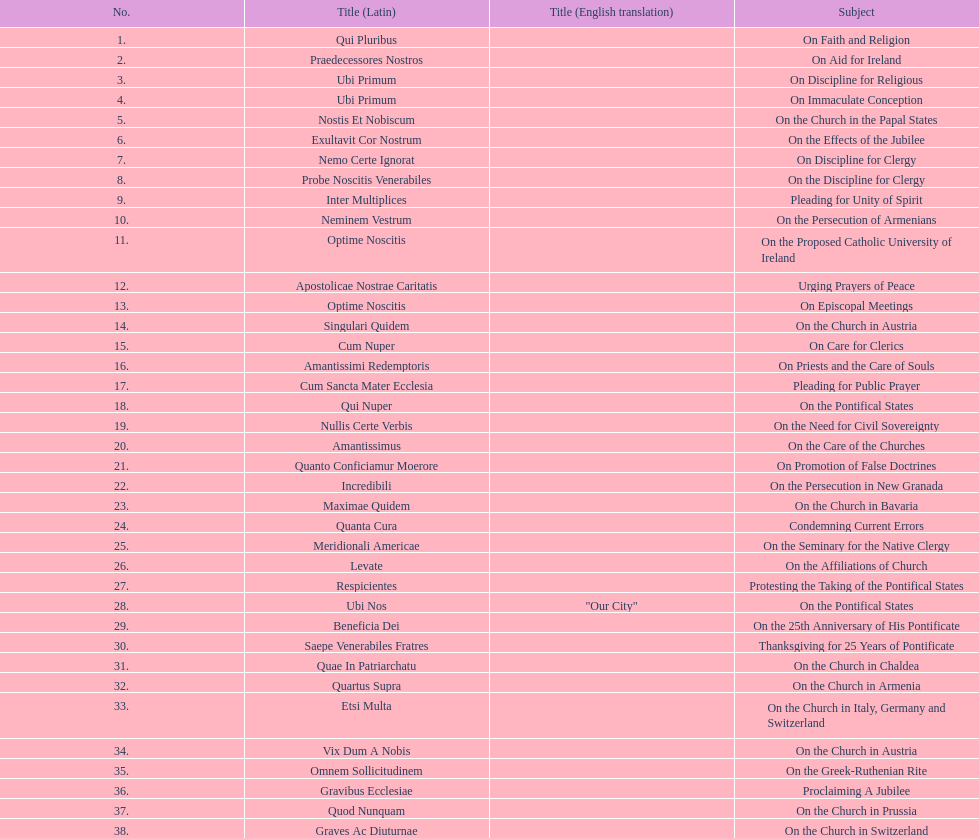In the first 10 years of his reign, how many encyclicals did pope pius ix issue? 14. 